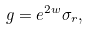Convert formula to latex. <formula><loc_0><loc_0><loc_500><loc_500>g = e ^ { 2 w } \sigma _ { r } ,</formula> 